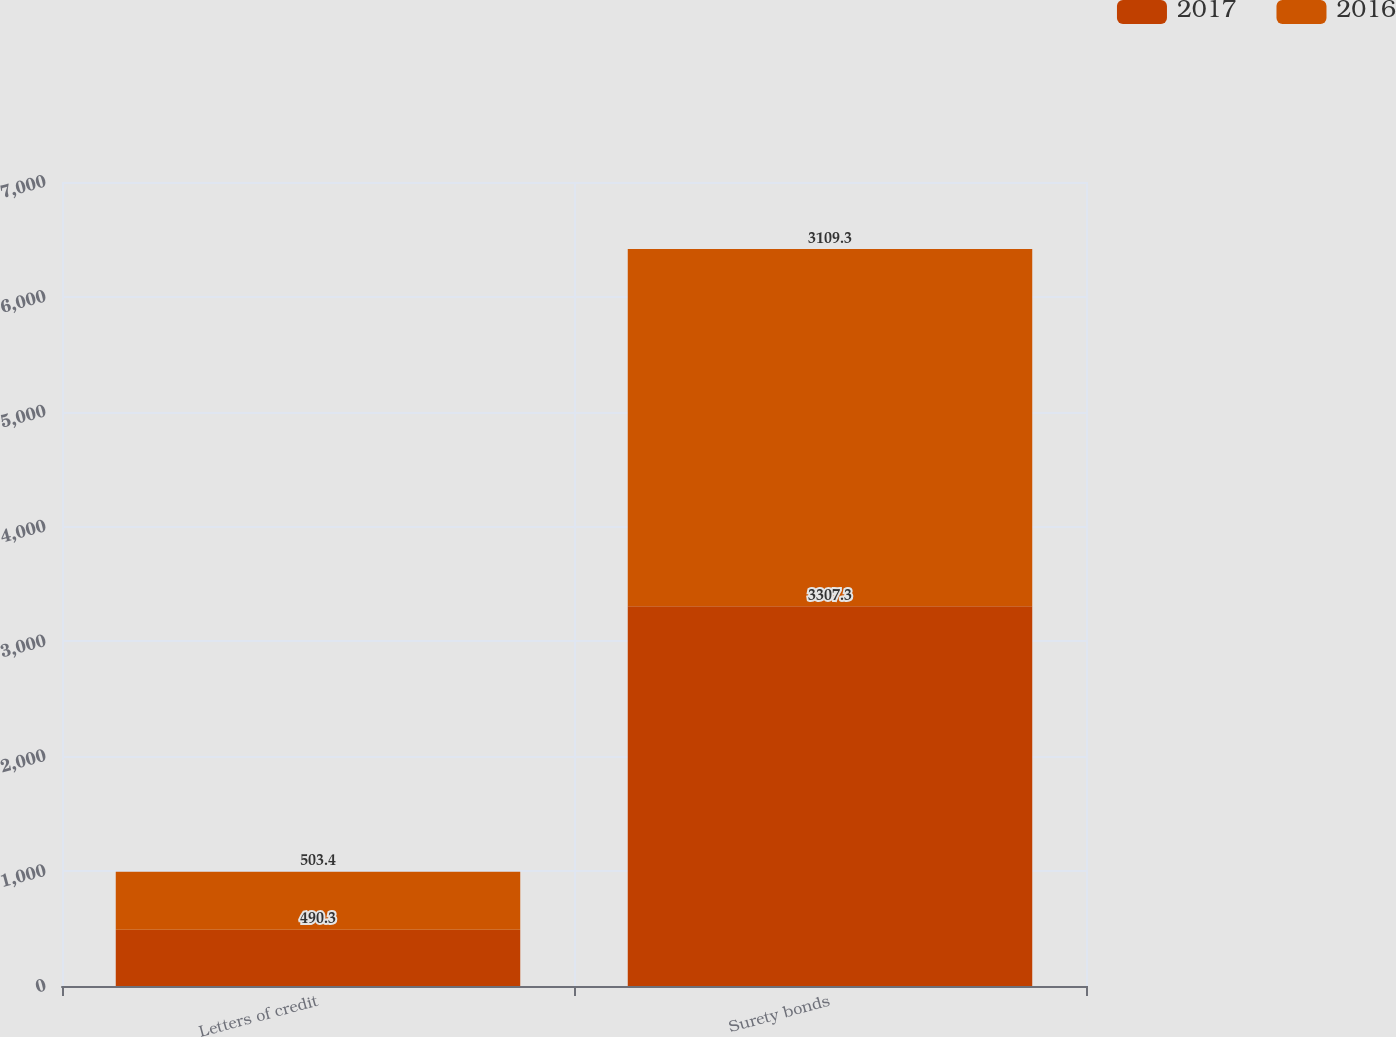<chart> <loc_0><loc_0><loc_500><loc_500><stacked_bar_chart><ecel><fcel>Letters of credit<fcel>Surety bonds<nl><fcel>2017<fcel>490.3<fcel>3307.3<nl><fcel>2016<fcel>503.4<fcel>3109.3<nl></chart> 